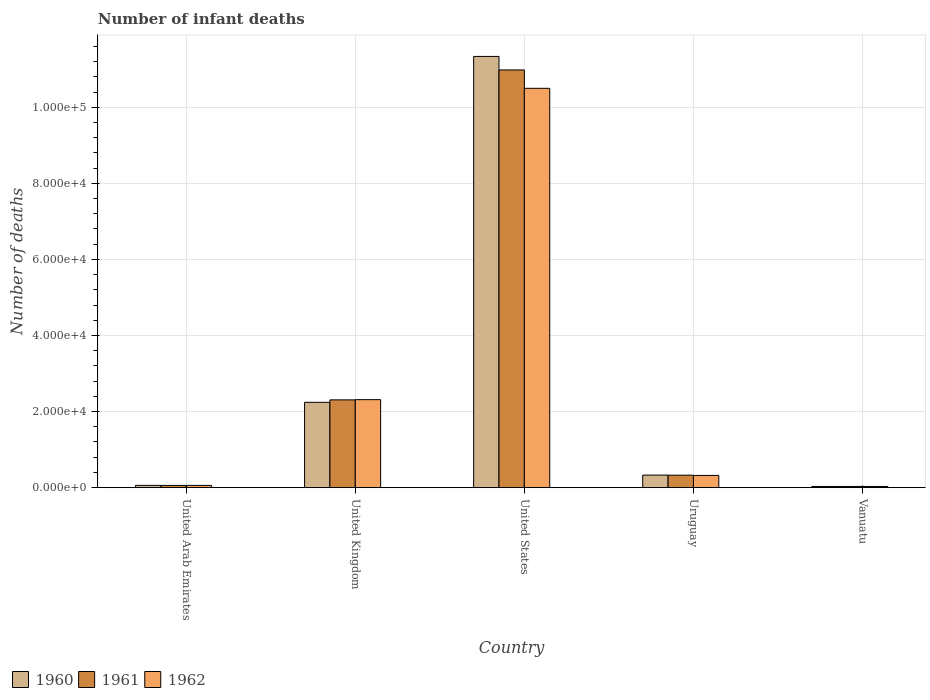How many different coloured bars are there?
Your answer should be very brief. 3. Are the number of bars per tick equal to the number of legend labels?
Keep it short and to the point. Yes. Are the number of bars on each tick of the X-axis equal?
Offer a very short reply. Yes. How many bars are there on the 2nd tick from the right?
Provide a short and direct response. 3. What is the label of the 4th group of bars from the left?
Make the answer very short. Uruguay. What is the number of infant deaths in 1961 in Vanuatu?
Offer a very short reply. 311. Across all countries, what is the maximum number of infant deaths in 1961?
Your answer should be compact. 1.10e+05. Across all countries, what is the minimum number of infant deaths in 1960?
Keep it short and to the point. 311. In which country was the number of infant deaths in 1961 maximum?
Offer a terse response. United States. In which country was the number of infant deaths in 1962 minimum?
Your response must be concise. Vanuatu. What is the total number of infant deaths in 1961 in the graph?
Provide a succinct answer. 1.37e+05. What is the difference between the number of infant deaths in 1960 in United Kingdom and that in Vanuatu?
Your answer should be compact. 2.21e+04. What is the difference between the number of infant deaths in 1961 in United States and the number of infant deaths in 1962 in United Kingdom?
Offer a very short reply. 8.67e+04. What is the average number of infant deaths in 1960 per country?
Offer a terse response. 2.80e+04. What is the ratio of the number of infant deaths in 1961 in United Kingdom to that in Vanuatu?
Ensure brevity in your answer.  74.19. What is the difference between the highest and the second highest number of infant deaths in 1961?
Ensure brevity in your answer.  -8.67e+04. What is the difference between the highest and the lowest number of infant deaths in 1960?
Provide a short and direct response. 1.13e+05. In how many countries, is the number of infant deaths in 1961 greater than the average number of infant deaths in 1961 taken over all countries?
Give a very brief answer. 1. Is the sum of the number of infant deaths in 1960 in United Kingdom and United States greater than the maximum number of infant deaths in 1962 across all countries?
Offer a terse response. Yes. What does the 3rd bar from the left in Vanuatu represents?
Give a very brief answer. 1962. How many bars are there?
Offer a terse response. 15. Are all the bars in the graph horizontal?
Make the answer very short. No. How many countries are there in the graph?
Your answer should be compact. 5. Are the values on the major ticks of Y-axis written in scientific E-notation?
Provide a succinct answer. Yes. Does the graph contain any zero values?
Your answer should be very brief. No. Does the graph contain grids?
Offer a very short reply. Yes. Where does the legend appear in the graph?
Make the answer very short. Bottom left. How are the legend labels stacked?
Give a very brief answer. Horizontal. What is the title of the graph?
Offer a terse response. Number of infant deaths. Does "1987" appear as one of the legend labels in the graph?
Offer a very short reply. No. What is the label or title of the Y-axis?
Your response must be concise. Number of deaths. What is the Number of deaths of 1960 in United Arab Emirates?
Provide a short and direct response. 598. What is the Number of deaths of 1961 in United Arab Emirates?
Your response must be concise. 582. What is the Number of deaths of 1962 in United Arab Emirates?
Ensure brevity in your answer.  587. What is the Number of deaths in 1960 in United Kingdom?
Your answer should be very brief. 2.24e+04. What is the Number of deaths in 1961 in United Kingdom?
Ensure brevity in your answer.  2.31e+04. What is the Number of deaths in 1962 in United Kingdom?
Your answer should be compact. 2.31e+04. What is the Number of deaths in 1960 in United States?
Offer a very short reply. 1.13e+05. What is the Number of deaths in 1961 in United States?
Keep it short and to the point. 1.10e+05. What is the Number of deaths in 1962 in United States?
Your response must be concise. 1.05e+05. What is the Number of deaths in 1960 in Uruguay?
Offer a terse response. 3301. What is the Number of deaths of 1961 in Uruguay?
Ensure brevity in your answer.  3277. What is the Number of deaths in 1962 in Uruguay?
Offer a terse response. 3216. What is the Number of deaths of 1960 in Vanuatu?
Provide a succinct answer. 311. What is the Number of deaths of 1961 in Vanuatu?
Your answer should be compact. 311. What is the Number of deaths of 1962 in Vanuatu?
Offer a very short reply. 311. Across all countries, what is the maximum Number of deaths in 1960?
Your answer should be very brief. 1.13e+05. Across all countries, what is the maximum Number of deaths of 1961?
Provide a succinct answer. 1.10e+05. Across all countries, what is the maximum Number of deaths in 1962?
Your response must be concise. 1.05e+05. Across all countries, what is the minimum Number of deaths of 1960?
Your answer should be compact. 311. Across all countries, what is the minimum Number of deaths in 1961?
Make the answer very short. 311. Across all countries, what is the minimum Number of deaths in 1962?
Give a very brief answer. 311. What is the total Number of deaths in 1960 in the graph?
Provide a succinct answer. 1.40e+05. What is the total Number of deaths in 1961 in the graph?
Your response must be concise. 1.37e+05. What is the total Number of deaths in 1962 in the graph?
Give a very brief answer. 1.32e+05. What is the difference between the Number of deaths in 1960 in United Arab Emirates and that in United Kingdom?
Give a very brief answer. -2.18e+04. What is the difference between the Number of deaths of 1961 in United Arab Emirates and that in United Kingdom?
Offer a terse response. -2.25e+04. What is the difference between the Number of deaths of 1962 in United Arab Emirates and that in United Kingdom?
Give a very brief answer. -2.25e+04. What is the difference between the Number of deaths in 1960 in United Arab Emirates and that in United States?
Keep it short and to the point. -1.13e+05. What is the difference between the Number of deaths in 1961 in United Arab Emirates and that in United States?
Give a very brief answer. -1.09e+05. What is the difference between the Number of deaths of 1962 in United Arab Emirates and that in United States?
Offer a very short reply. -1.04e+05. What is the difference between the Number of deaths in 1960 in United Arab Emirates and that in Uruguay?
Provide a succinct answer. -2703. What is the difference between the Number of deaths in 1961 in United Arab Emirates and that in Uruguay?
Your response must be concise. -2695. What is the difference between the Number of deaths of 1962 in United Arab Emirates and that in Uruguay?
Your answer should be very brief. -2629. What is the difference between the Number of deaths in 1960 in United Arab Emirates and that in Vanuatu?
Provide a succinct answer. 287. What is the difference between the Number of deaths in 1961 in United Arab Emirates and that in Vanuatu?
Your answer should be compact. 271. What is the difference between the Number of deaths in 1962 in United Arab Emirates and that in Vanuatu?
Provide a short and direct response. 276. What is the difference between the Number of deaths of 1960 in United Kingdom and that in United States?
Offer a very short reply. -9.09e+04. What is the difference between the Number of deaths of 1961 in United Kingdom and that in United States?
Provide a succinct answer. -8.67e+04. What is the difference between the Number of deaths of 1962 in United Kingdom and that in United States?
Your answer should be compact. -8.18e+04. What is the difference between the Number of deaths in 1960 in United Kingdom and that in Uruguay?
Your answer should be compact. 1.91e+04. What is the difference between the Number of deaths in 1961 in United Kingdom and that in Uruguay?
Keep it short and to the point. 1.98e+04. What is the difference between the Number of deaths in 1962 in United Kingdom and that in Uruguay?
Offer a terse response. 1.99e+04. What is the difference between the Number of deaths in 1960 in United Kingdom and that in Vanuatu?
Offer a very short reply. 2.21e+04. What is the difference between the Number of deaths in 1961 in United Kingdom and that in Vanuatu?
Ensure brevity in your answer.  2.28e+04. What is the difference between the Number of deaths in 1962 in United Kingdom and that in Vanuatu?
Ensure brevity in your answer.  2.28e+04. What is the difference between the Number of deaths of 1960 in United States and that in Uruguay?
Your answer should be compact. 1.10e+05. What is the difference between the Number of deaths in 1961 in United States and that in Uruguay?
Ensure brevity in your answer.  1.07e+05. What is the difference between the Number of deaths in 1962 in United States and that in Uruguay?
Give a very brief answer. 1.02e+05. What is the difference between the Number of deaths of 1960 in United States and that in Vanuatu?
Your answer should be compact. 1.13e+05. What is the difference between the Number of deaths of 1961 in United States and that in Vanuatu?
Your answer should be compact. 1.09e+05. What is the difference between the Number of deaths of 1962 in United States and that in Vanuatu?
Your response must be concise. 1.05e+05. What is the difference between the Number of deaths of 1960 in Uruguay and that in Vanuatu?
Give a very brief answer. 2990. What is the difference between the Number of deaths of 1961 in Uruguay and that in Vanuatu?
Provide a short and direct response. 2966. What is the difference between the Number of deaths in 1962 in Uruguay and that in Vanuatu?
Give a very brief answer. 2905. What is the difference between the Number of deaths in 1960 in United Arab Emirates and the Number of deaths in 1961 in United Kingdom?
Keep it short and to the point. -2.25e+04. What is the difference between the Number of deaths in 1960 in United Arab Emirates and the Number of deaths in 1962 in United Kingdom?
Give a very brief answer. -2.25e+04. What is the difference between the Number of deaths of 1961 in United Arab Emirates and the Number of deaths of 1962 in United Kingdom?
Ensure brevity in your answer.  -2.26e+04. What is the difference between the Number of deaths of 1960 in United Arab Emirates and the Number of deaths of 1961 in United States?
Offer a terse response. -1.09e+05. What is the difference between the Number of deaths of 1960 in United Arab Emirates and the Number of deaths of 1962 in United States?
Your answer should be very brief. -1.04e+05. What is the difference between the Number of deaths of 1961 in United Arab Emirates and the Number of deaths of 1962 in United States?
Your answer should be compact. -1.04e+05. What is the difference between the Number of deaths in 1960 in United Arab Emirates and the Number of deaths in 1961 in Uruguay?
Keep it short and to the point. -2679. What is the difference between the Number of deaths in 1960 in United Arab Emirates and the Number of deaths in 1962 in Uruguay?
Your answer should be compact. -2618. What is the difference between the Number of deaths in 1961 in United Arab Emirates and the Number of deaths in 1962 in Uruguay?
Your response must be concise. -2634. What is the difference between the Number of deaths in 1960 in United Arab Emirates and the Number of deaths in 1961 in Vanuatu?
Provide a succinct answer. 287. What is the difference between the Number of deaths in 1960 in United Arab Emirates and the Number of deaths in 1962 in Vanuatu?
Keep it short and to the point. 287. What is the difference between the Number of deaths of 1961 in United Arab Emirates and the Number of deaths of 1962 in Vanuatu?
Keep it short and to the point. 271. What is the difference between the Number of deaths of 1960 in United Kingdom and the Number of deaths of 1961 in United States?
Give a very brief answer. -8.74e+04. What is the difference between the Number of deaths in 1960 in United Kingdom and the Number of deaths in 1962 in United States?
Your answer should be compact. -8.25e+04. What is the difference between the Number of deaths in 1961 in United Kingdom and the Number of deaths in 1962 in United States?
Your response must be concise. -8.19e+04. What is the difference between the Number of deaths of 1960 in United Kingdom and the Number of deaths of 1961 in Uruguay?
Your response must be concise. 1.92e+04. What is the difference between the Number of deaths of 1960 in United Kingdom and the Number of deaths of 1962 in Uruguay?
Offer a very short reply. 1.92e+04. What is the difference between the Number of deaths in 1961 in United Kingdom and the Number of deaths in 1962 in Uruguay?
Keep it short and to the point. 1.99e+04. What is the difference between the Number of deaths of 1960 in United Kingdom and the Number of deaths of 1961 in Vanuatu?
Provide a short and direct response. 2.21e+04. What is the difference between the Number of deaths of 1960 in United Kingdom and the Number of deaths of 1962 in Vanuatu?
Your answer should be compact. 2.21e+04. What is the difference between the Number of deaths in 1961 in United Kingdom and the Number of deaths in 1962 in Vanuatu?
Give a very brief answer. 2.28e+04. What is the difference between the Number of deaths of 1960 in United States and the Number of deaths of 1961 in Uruguay?
Give a very brief answer. 1.10e+05. What is the difference between the Number of deaths in 1960 in United States and the Number of deaths in 1962 in Uruguay?
Give a very brief answer. 1.10e+05. What is the difference between the Number of deaths of 1961 in United States and the Number of deaths of 1962 in Uruguay?
Provide a succinct answer. 1.07e+05. What is the difference between the Number of deaths of 1960 in United States and the Number of deaths of 1961 in Vanuatu?
Your response must be concise. 1.13e+05. What is the difference between the Number of deaths of 1960 in United States and the Number of deaths of 1962 in Vanuatu?
Provide a succinct answer. 1.13e+05. What is the difference between the Number of deaths in 1961 in United States and the Number of deaths in 1962 in Vanuatu?
Provide a short and direct response. 1.09e+05. What is the difference between the Number of deaths of 1960 in Uruguay and the Number of deaths of 1961 in Vanuatu?
Provide a succinct answer. 2990. What is the difference between the Number of deaths in 1960 in Uruguay and the Number of deaths in 1962 in Vanuatu?
Make the answer very short. 2990. What is the difference between the Number of deaths in 1961 in Uruguay and the Number of deaths in 1962 in Vanuatu?
Ensure brevity in your answer.  2966. What is the average Number of deaths in 1960 per country?
Your response must be concise. 2.80e+04. What is the average Number of deaths in 1961 per country?
Ensure brevity in your answer.  2.74e+04. What is the average Number of deaths of 1962 per country?
Offer a terse response. 2.64e+04. What is the difference between the Number of deaths of 1960 and Number of deaths of 1961 in United Arab Emirates?
Provide a succinct answer. 16. What is the difference between the Number of deaths in 1961 and Number of deaths in 1962 in United Arab Emirates?
Offer a very short reply. -5. What is the difference between the Number of deaths in 1960 and Number of deaths in 1961 in United Kingdom?
Make the answer very short. -642. What is the difference between the Number of deaths of 1960 and Number of deaths of 1962 in United Kingdom?
Make the answer very short. -702. What is the difference between the Number of deaths of 1961 and Number of deaths of 1962 in United Kingdom?
Your response must be concise. -60. What is the difference between the Number of deaths of 1960 and Number of deaths of 1961 in United States?
Your response must be concise. 3550. What is the difference between the Number of deaths in 1960 and Number of deaths in 1962 in United States?
Ensure brevity in your answer.  8380. What is the difference between the Number of deaths in 1961 and Number of deaths in 1962 in United States?
Your answer should be very brief. 4830. What is the difference between the Number of deaths of 1960 and Number of deaths of 1961 in Uruguay?
Your response must be concise. 24. What is the difference between the Number of deaths of 1960 and Number of deaths of 1962 in Uruguay?
Offer a terse response. 85. What is the difference between the Number of deaths in 1961 and Number of deaths in 1962 in Uruguay?
Your answer should be very brief. 61. What is the difference between the Number of deaths of 1961 and Number of deaths of 1962 in Vanuatu?
Offer a very short reply. 0. What is the ratio of the Number of deaths of 1960 in United Arab Emirates to that in United Kingdom?
Make the answer very short. 0.03. What is the ratio of the Number of deaths of 1961 in United Arab Emirates to that in United Kingdom?
Keep it short and to the point. 0.03. What is the ratio of the Number of deaths of 1962 in United Arab Emirates to that in United Kingdom?
Keep it short and to the point. 0.03. What is the ratio of the Number of deaths in 1960 in United Arab Emirates to that in United States?
Keep it short and to the point. 0.01. What is the ratio of the Number of deaths in 1961 in United Arab Emirates to that in United States?
Offer a terse response. 0.01. What is the ratio of the Number of deaths of 1962 in United Arab Emirates to that in United States?
Make the answer very short. 0.01. What is the ratio of the Number of deaths of 1960 in United Arab Emirates to that in Uruguay?
Provide a succinct answer. 0.18. What is the ratio of the Number of deaths in 1961 in United Arab Emirates to that in Uruguay?
Make the answer very short. 0.18. What is the ratio of the Number of deaths of 1962 in United Arab Emirates to that in Uruguay?
Offer a terse response. 0.18. What is the ratio of the Number of deaths of 1960 in United Arab Emirates to that in Vanuatu?
Ensure brevity in your answer.  1.92. What is the ratio of the Number of deaths of 1961 in United Arab Emirates to that in Vanuatu?
Ensure brevity in your answer.  1.87. What is the ratio of the Number of deaths in 1962 in United Arab Emirates to that in Vanuatu?
Your response must be concise. 1.89. What is the ratio of the Number of deaths of 1960 in United Kingdom to that in United States?
Your answer should be very brief. 0.2. What is the ratio of the Number of deaths of 1961 in United Kingdom to that in United States?
Offer a terse response. 0.21. What is the ratio of the Number of deaths of 1962 in United Kingdom to that in United States?
Offer a terse response. 0.22. What is the ratio of the Number of deaths of 1960 in United Kingdom to that in Uruguay?
Make the answer very short. 6.79. What is the ratio of the Number of deaths of 1961 in United Kingdom to that in Uruguay?
Provide a short and direct response. 7.04. What is the ratio of the Number of deaths of 1962 in United Kingdom to that in Uruguay?
Ensure brevity in your answer.  7.19. What is the ratio of the Number of deaths of 1960 in United Kingdom to that in Vanuatu?
Your answer should be compact. 72.12. What is the ratio of the Number of deaths in 1961 in United Kingdom to that in Vanuatu?
Keep it short and to the point. 74.19. What is the ratio of the Number of deaths in 1962 in United Kingdom to that in Vanuatu?
Your answer should be compact. 74.38. What is the ratio of the Number of deaths in 1960 in United States to that in Uruguay?
Your answer should be compact. 34.34. What is the ratio of the Number of deaths of 1961 in United States to that in Uruguay?
Your answer should be very brief. 33.51. What is the ratio of the Number of deaths of 1962 in United States to that in Uruguay?
Your answer should be compact. 32.64. What is the ratio of the Number of deaths in 1960 in United States to that in Vanuatu?
Make the answer very short. 364.48. What is the ratio of the Number of deaths in 1961 in United States to that in Vanuatu?
Give a very brief answer. 353.07. What is the ratio of the Number of deaths in 1962 in United States to that in Vanuatu?
Keep it short and to the point. 337.54. What is the ratio of the Number of deaths in 1960 in Uruguay to that in Vanuatu?
Your answer should be compact. 10.61. What is the ratio of the Number of deaths of 1961 in Uruguay to that in Vanuatu?
Provide a short and direct response. 10.54. What is the ratio of the Number of deaths of 1962 in Uruguay to that in Vanuatu?
Provide a short and direct response. 10.34. What is the difference between the highest and the second highest Number of deaths of 1960?
Ensure brevity in your answer.  9.09e+04. What is the difference between the highest and the second highest Number of deaths of 1961?
Ensure brevity in your answer.  8.67e+04. What is the difference between the highest and the second highest Number of deaths of 1962?
Keep it short and to the point. 8.18e+04. What is the difference between the highest and the lowest Number of deaths in 1960?
Make the answer very short. 1.13e+05. What is the difference between the highest and the lowest Number of deaths of 1961?
Provide a succinct answer. 1.09e+05. What is the difference between the highest and the lowest Number of deaths of 1962?
Your answer should be compact. 1.05e+05. 